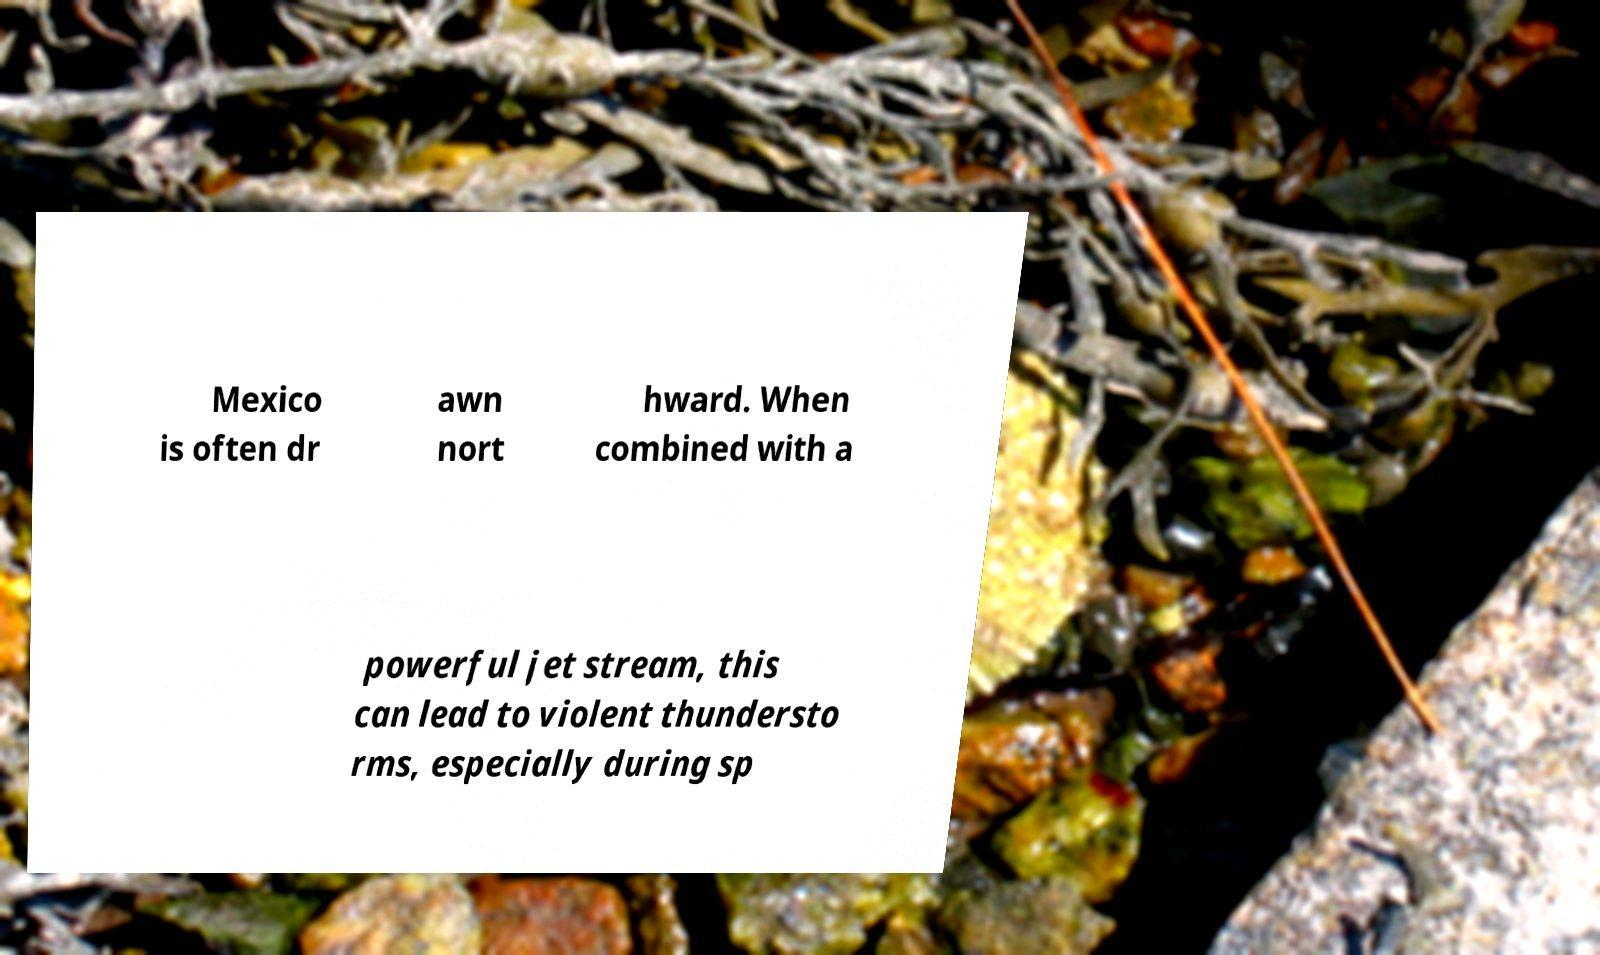Can you accurately transcribe the text from the provided image for me? Mexico is often dr awn nort hward. When combined with a powerful jet stream, this can lead to violent thundersto rms, especially during sp 